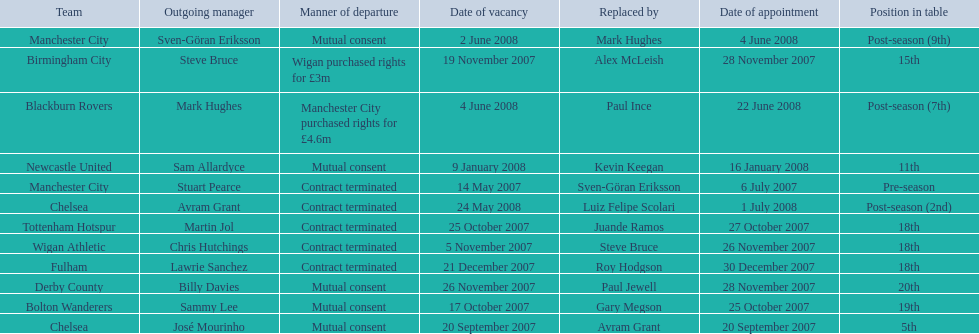What team is listed after manchester city? Chelsea. 